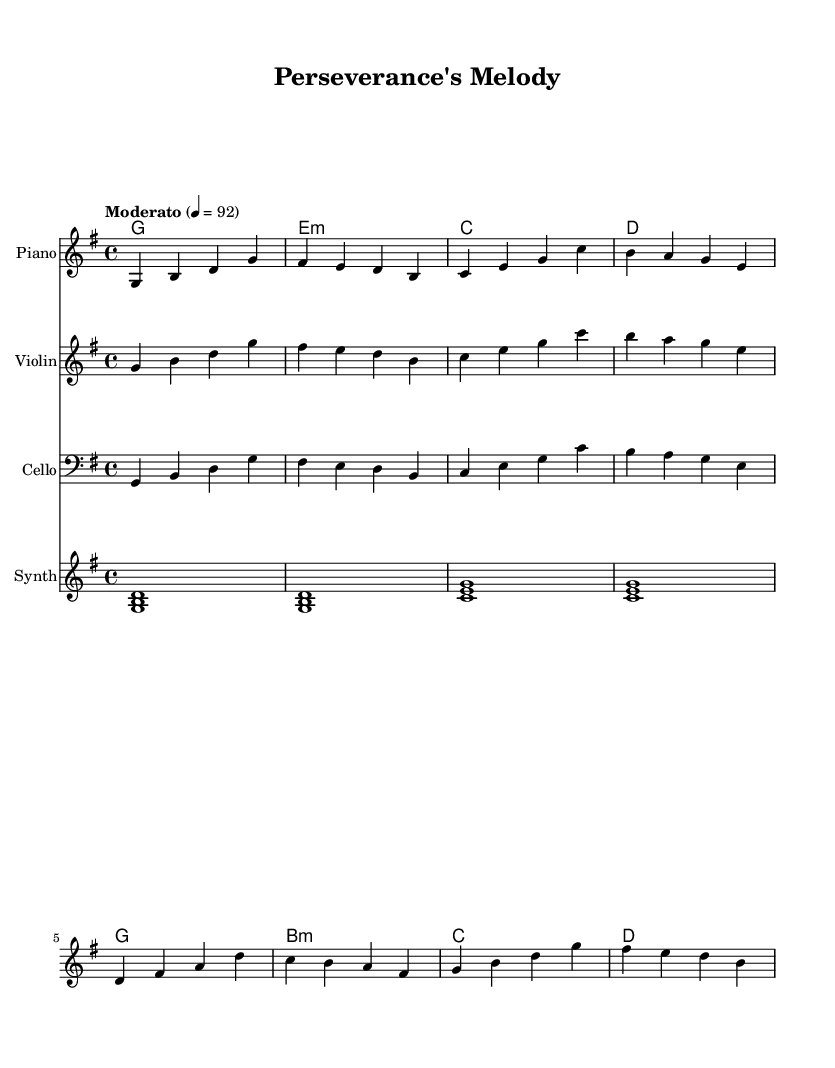What is the key signature of this music? The key signature indicates that the music is in G major, which has one sharp (F sharp). This is indicated at the beginning of the staff before the notes start.
Answer: G major What is the time signature of this piece? The time signature is found at the beginning of the staff. It indicates that there are four beats in each measure and that a quarter note receives one beat. This is represented by the "4/4" notation.
Answer: 4/4 What is the tempo marking of this piece? The tempo marking indicates the speed of the music. It is found above the staff and reads "Moderato" with a metronome marking of 92 beats per minute, which shows it should be played at a moderate pace.
Answer: Moderato 92 How many measures are in the piano part? To determine the number of measures, I can count each vertical line separating groups of notes. There are a total of eight measures in the piano part, as indicated by these vertical lines.
Answer: 8 What is the harmonic sequence of the chord progression? The chord progression can be seen in the ChordNames staff, which outlines the chords being played. The chords appear in the sequence: G, E minor, C, D, G, B minor, C, D. This logical sequence creates a foundation for the melody and harmony throughout the piece.
Answer: G, E minor, C, D, G, B minor, C, D Which instruments are featured in this score? By looking at the score layout, I can identify all the instruments indicated in the individual staff sections. The instruments featured are Piano, Violin, Cello, and Synth, each corresponding to a unique staff.
Answer: Piano, Violin, Cello, Synth 